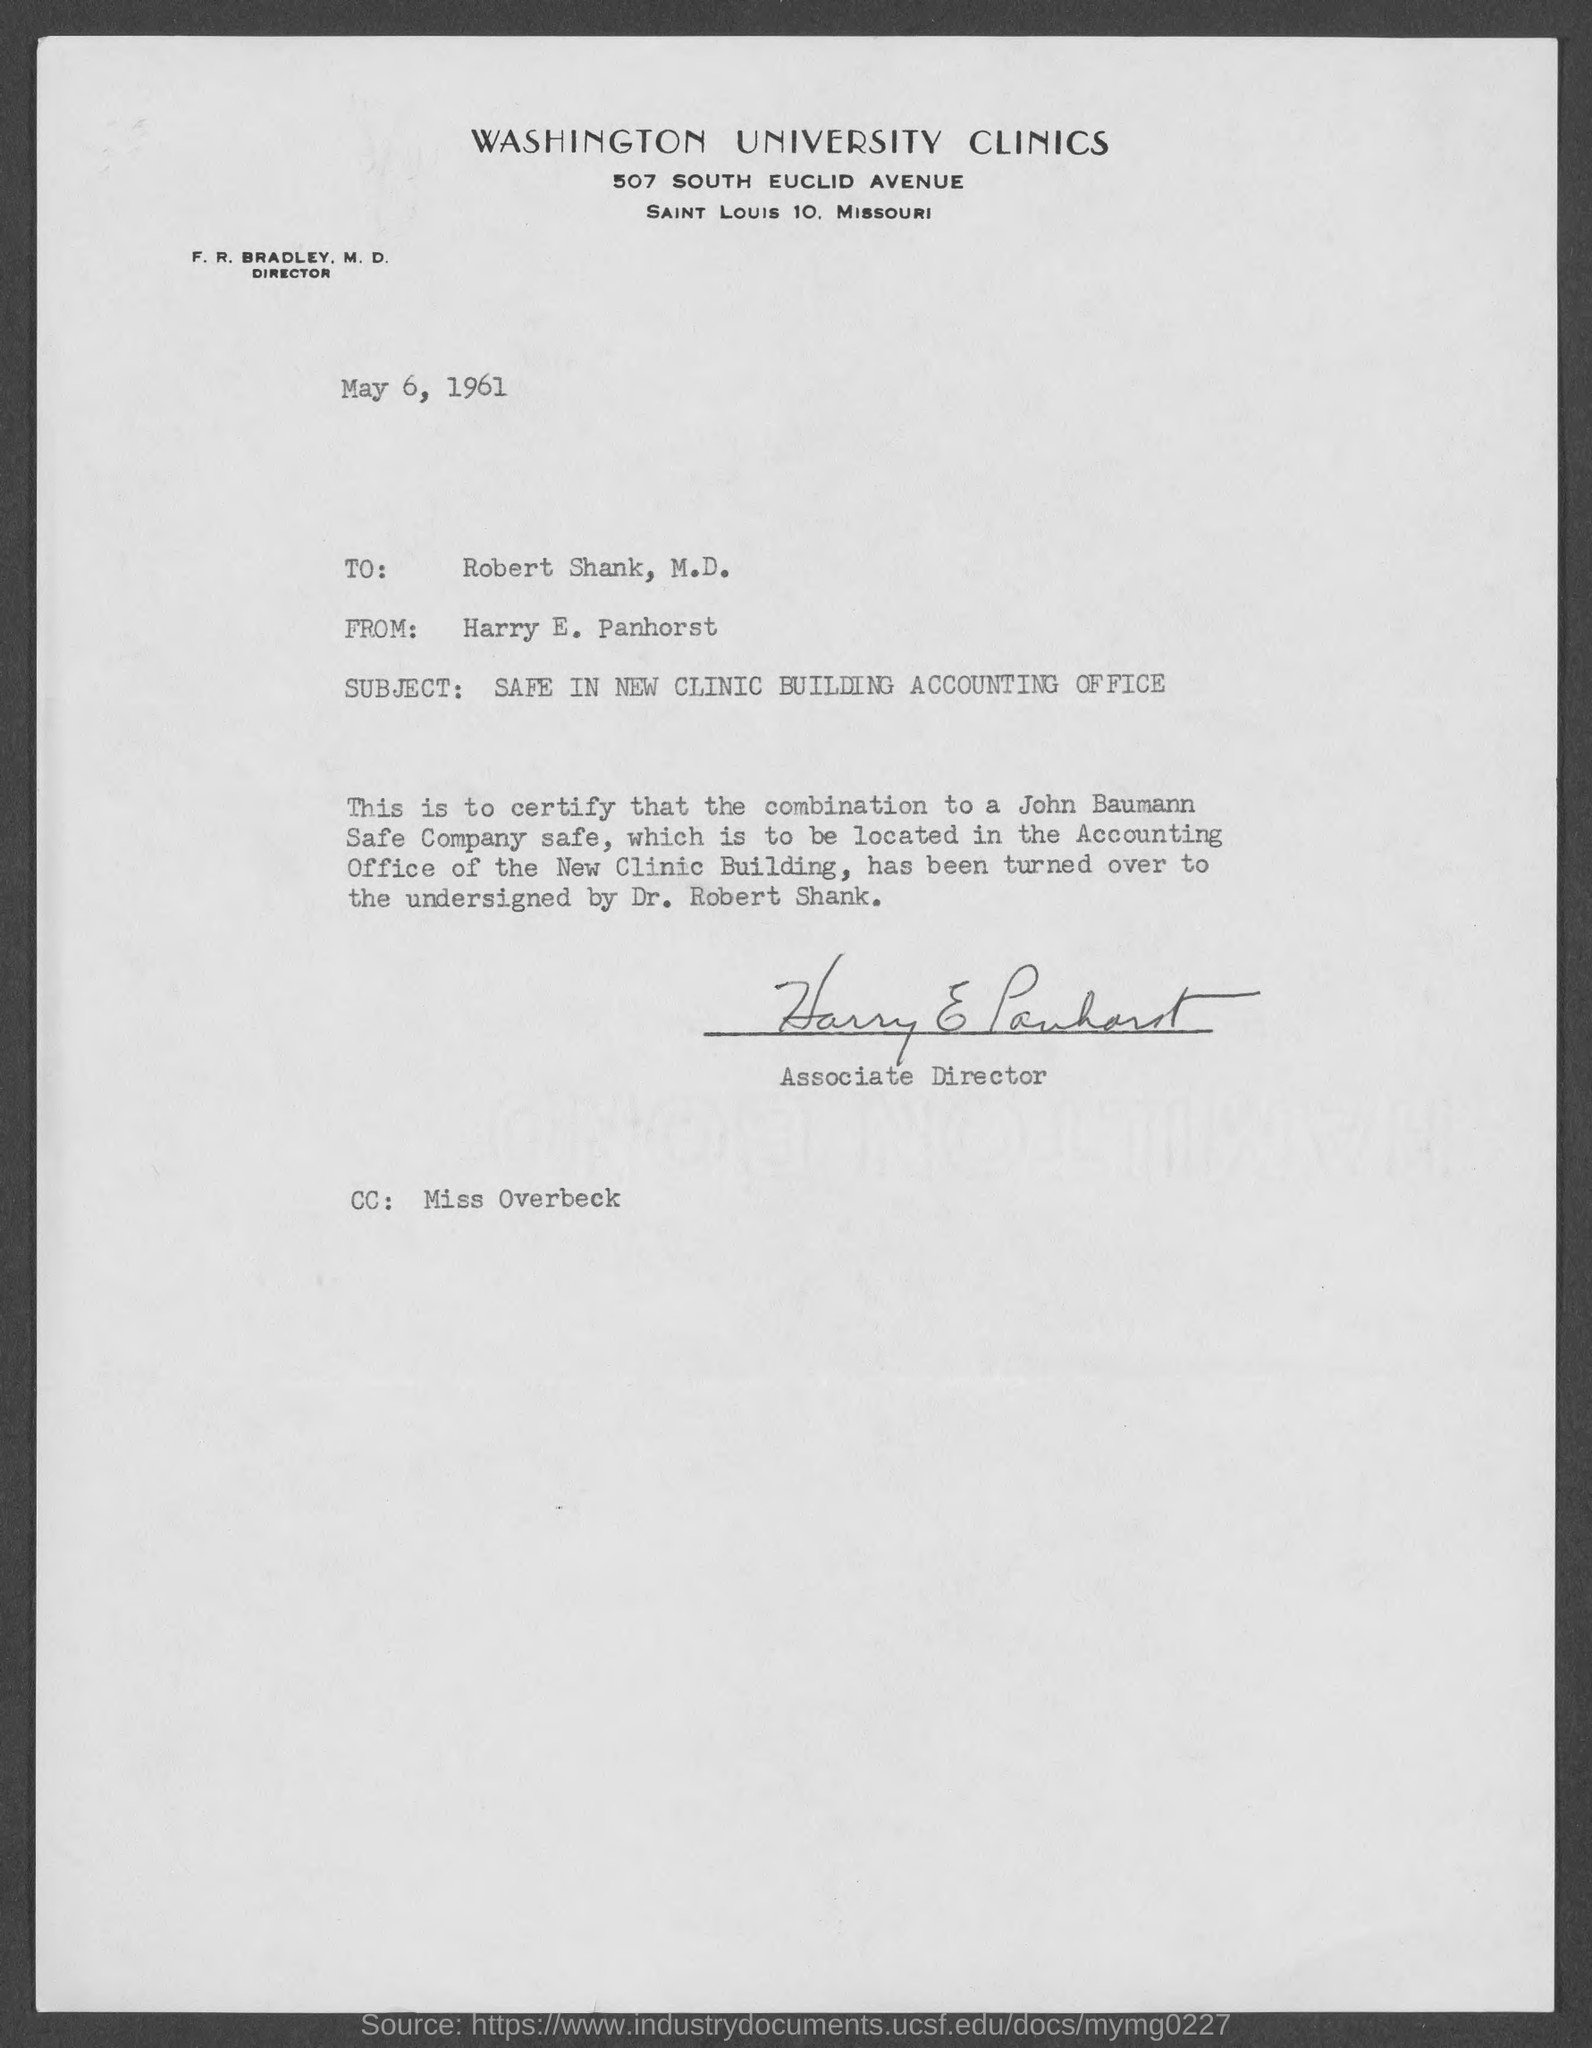What is the street address of washington university clinics?
Your response must be concise. 507 South Euclid Avenue. When is the letter dated ?
Provide a succinct answer. May 6, 1961. To whom is this letter written to?
Your answer should be compact. Robert Shank, M.D. Who wrote this letter ?
Ensure brevity in your answer.  Harry E. Panhorst. What is the subject of the letter ?
Ensure brevity in your answer.  Safe in New Clinic Building Accounting Office. What is the position of harry e. panhorst ?
Make the answer very short. Associate Director. 